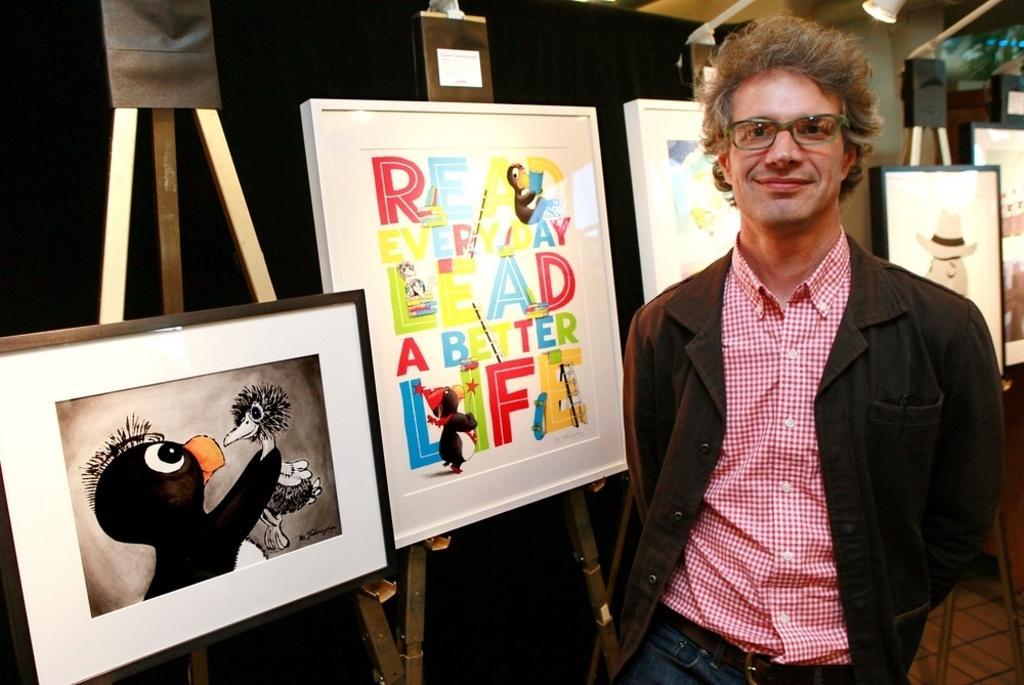Describe this image in one or two sentences. In this image on the right there is a man, he wears a suit, shirt, trouser. On the left there are photo frames, boards, stands. In the background there are lights, curtains, stands and wall. 